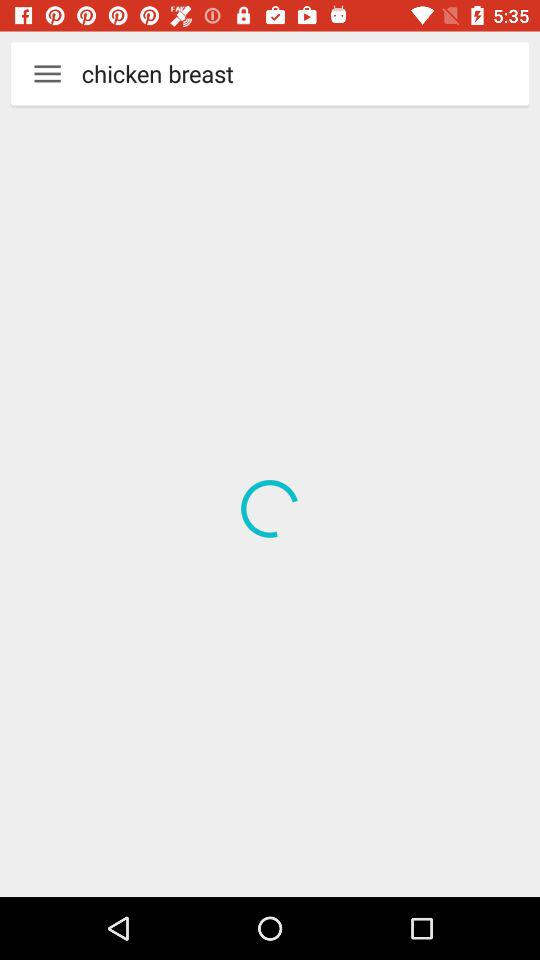How many hearts are given to "The Cake Doctor's Red Velvet Cake"? The number of hearts given to "The Cake Doctor's Red Velvet Cake" is 18. 